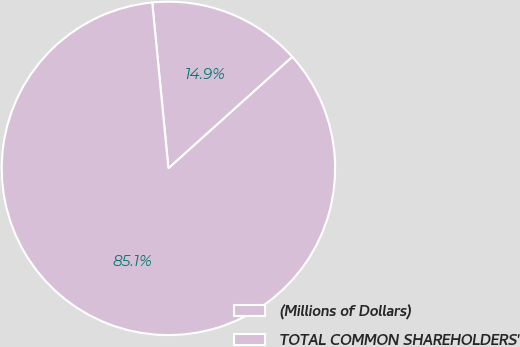Convert chart. <chart><loc_0><loc_0><loc_500><loc_500><pie_chart><fcel>(Millions of Dollars)<fcel>TOTAL COMMON SHAREHOLDERS'<nl><fcel>14.89%<fcel>85.11%<nl></chart> 